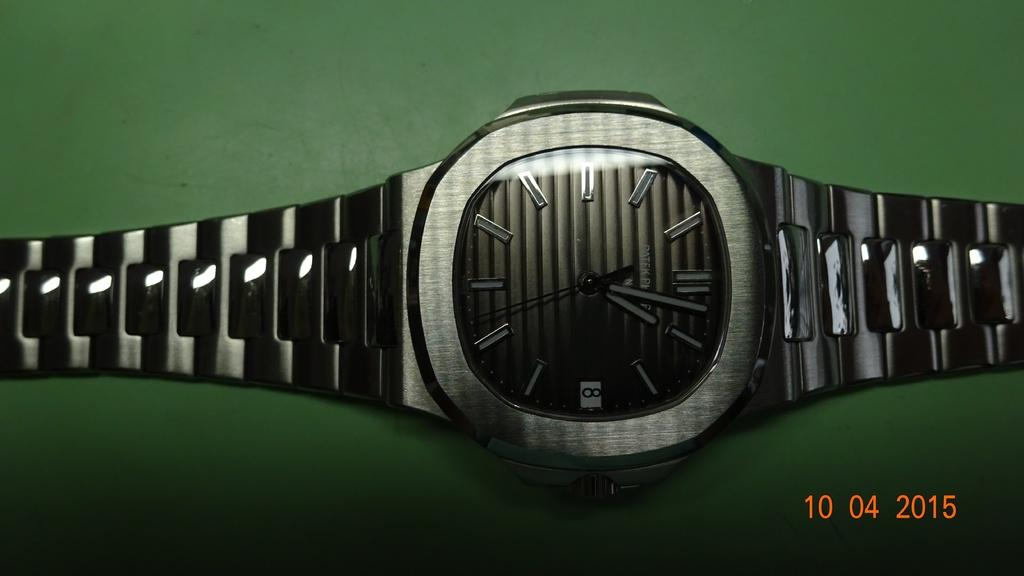<image>
Describe the image concisely. A Patek brand watch displays the number 8 on its face. 